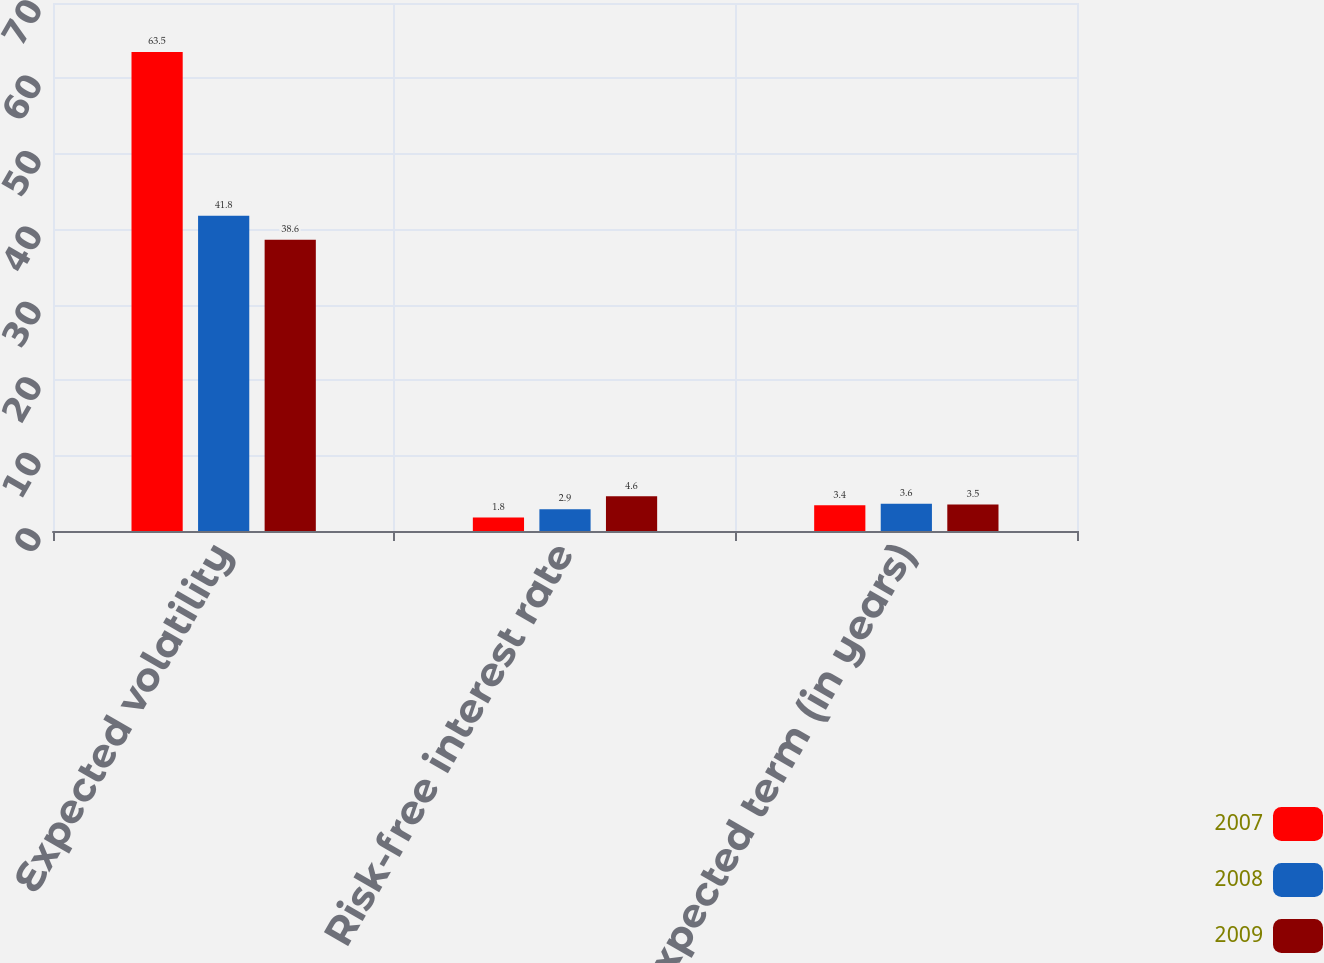<chart> <loc_0><loc_0><loc_500><loc_500><stacked_bar_chart><ecel><fcel>Expected volatility<fcel>Risk-free interest rate<fcel>Expected term (in years)<nl><fcel>2007<fcel>63.5<fcel>1.8<fcel>3.4<nl><fcel>2008<fcel>41.8<fcel>2.9<fcel>3.6<nl><fcel>2009<fcel>38.6<fcel>4.6<fcel>3.5<nl></chart> 